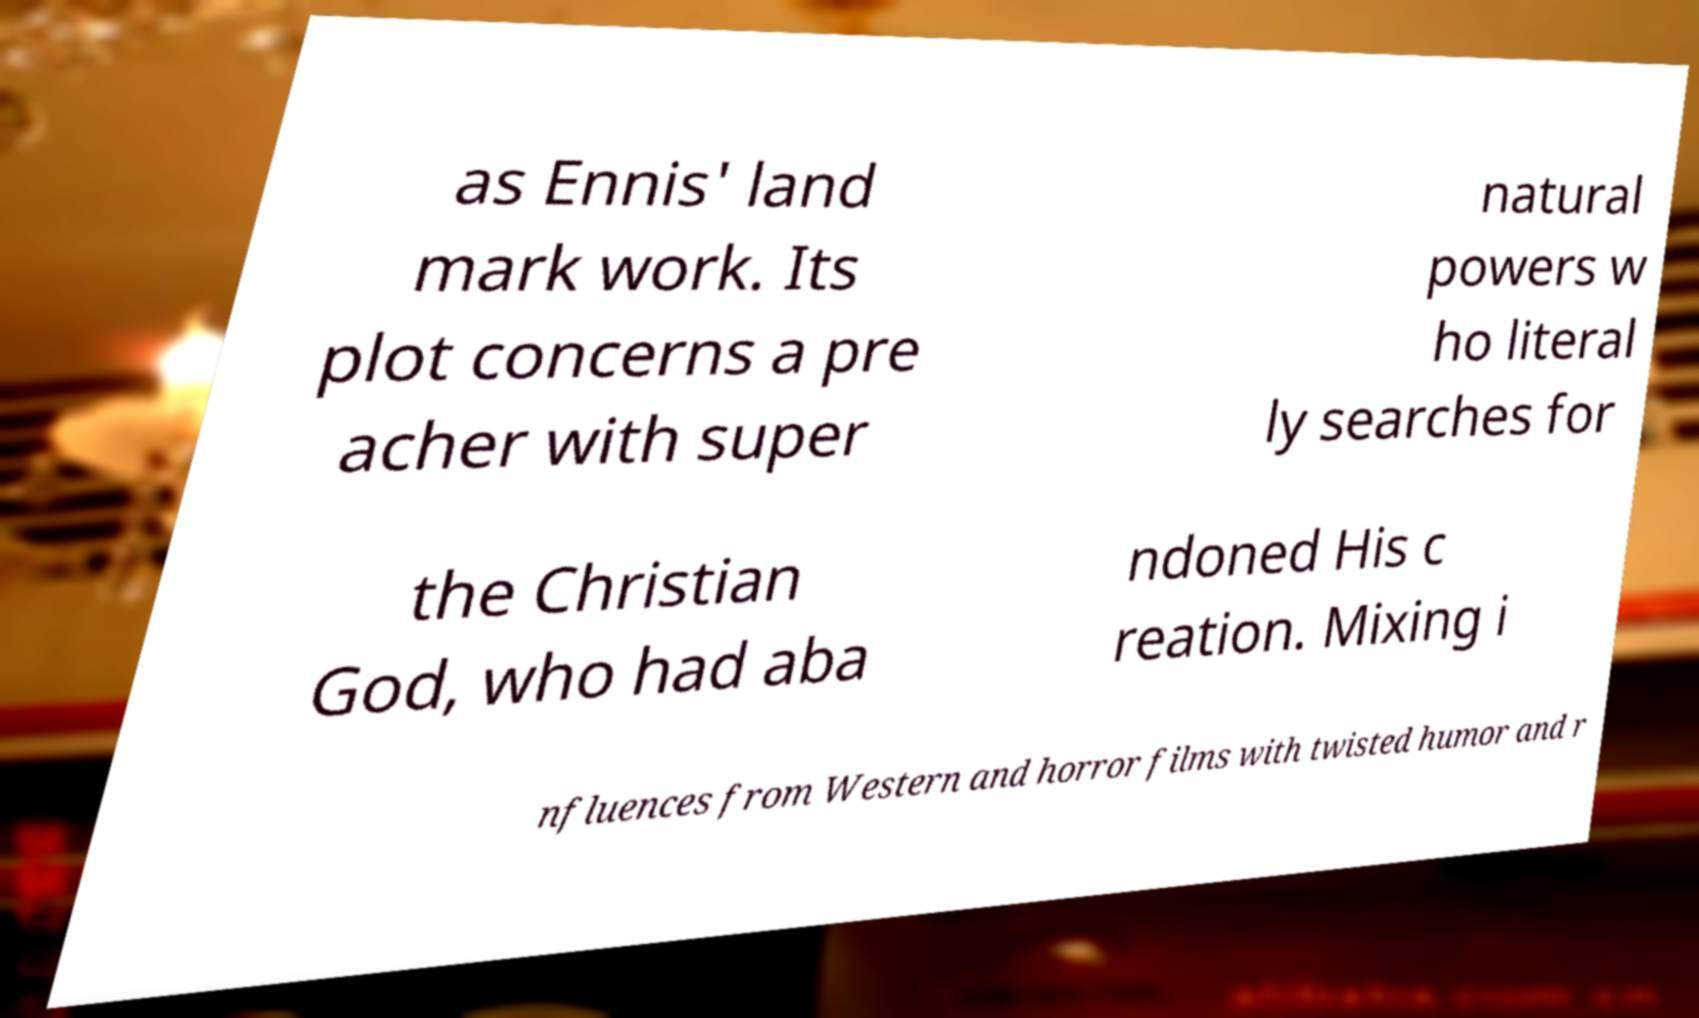Please identify and transcribe the text found in this image. as Ennis' land mark work. Its plot concerns a pre acher with super natural powers w ho literal ly searches for the Christian God, who had aba ndoned His c reation. Mixing i nfluences from Western and horror films with twisted humor and r 